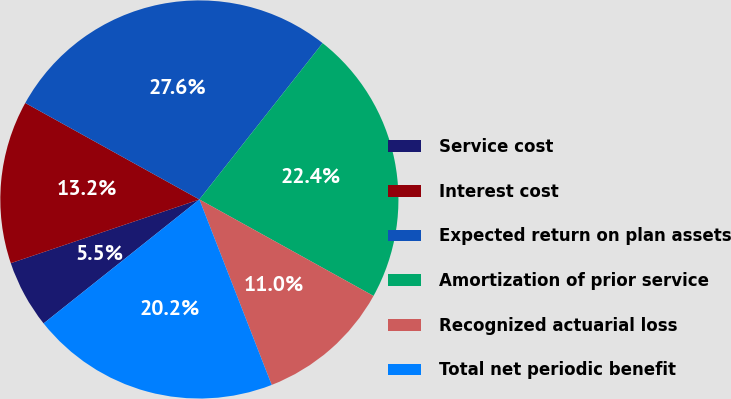Convert chart. <chart><loc_0><loc_0><loc_500><loc_500><pie_chart><fcel>Service cost<fcel>Interest cost<fcel>Expected return on plan assets<fcel>Amortization of prior service<fcel>Recognized actuarial loss<fcel>Total net periodic benefit<nl><fcel>5.51%<fcel>13.24%<fcel>27.57%<fcel>22.43%<fcel>11.03%<fcel>20.22%<nl></chart> 